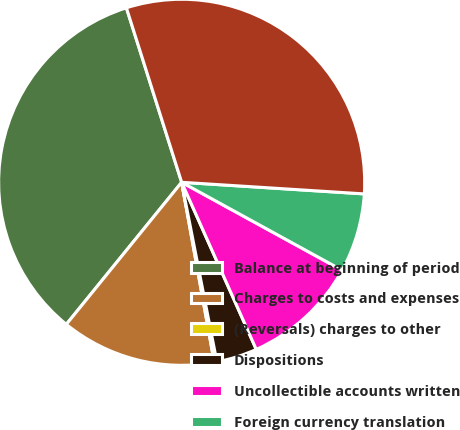Convert chart. <chart><loc_0><loc_0><loc_500><loc_500><pie_chart><fcel>Balance at beginning of period<fcel>Charges to costs and expenses<fcel>(Reversals) charges to other<fcel>Dispositions<fcel>Uncollectible accounts written<fcel>Foreign currency translation<fcel>Balance at end of period<nl><fcel>34.27%<fcel>13.71%<fcel>0.23%<fcel>3.6%<fcel>10.34%<fcel>6.97%<fcel>30.9%<nl></chart> 